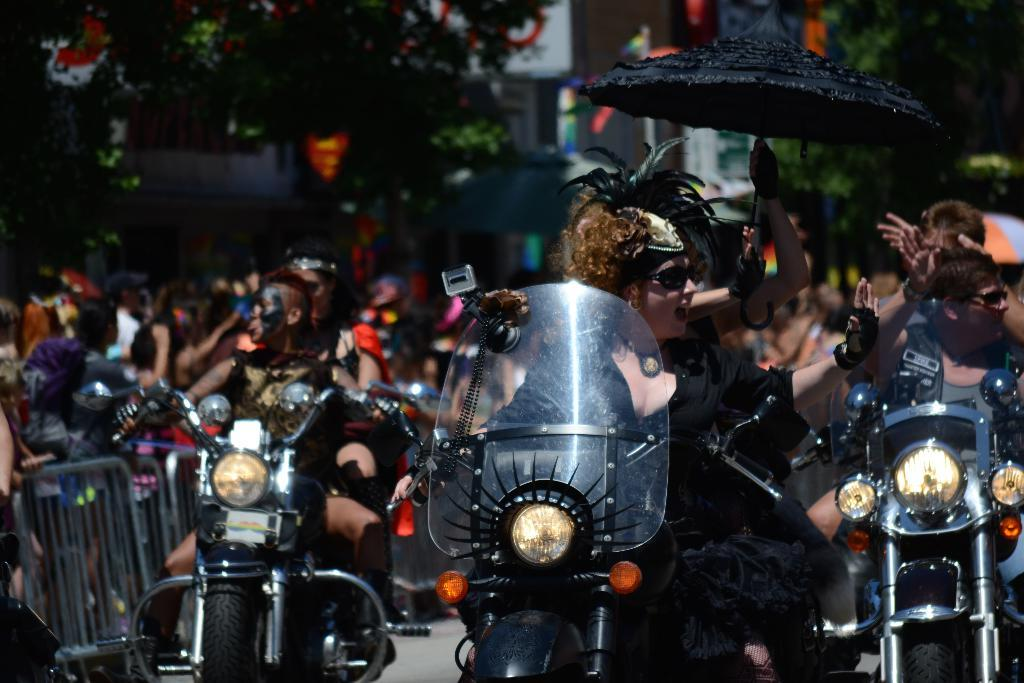What are the persons in the image doing? The persons in the image are riding bikes. Can you describe the background of the image? There are many persons, trees, and buildings in the background of the image. How many elements can be seen in the background of the image? There are three elements in the background: persons, trees, and buildings. What type of drug is being sold by the person on the bike in the image? There is no person selling drugs on a bike in the image. Can you tell me the date of the event shown in the image based on the calendar? There is no calendar present in the image. 